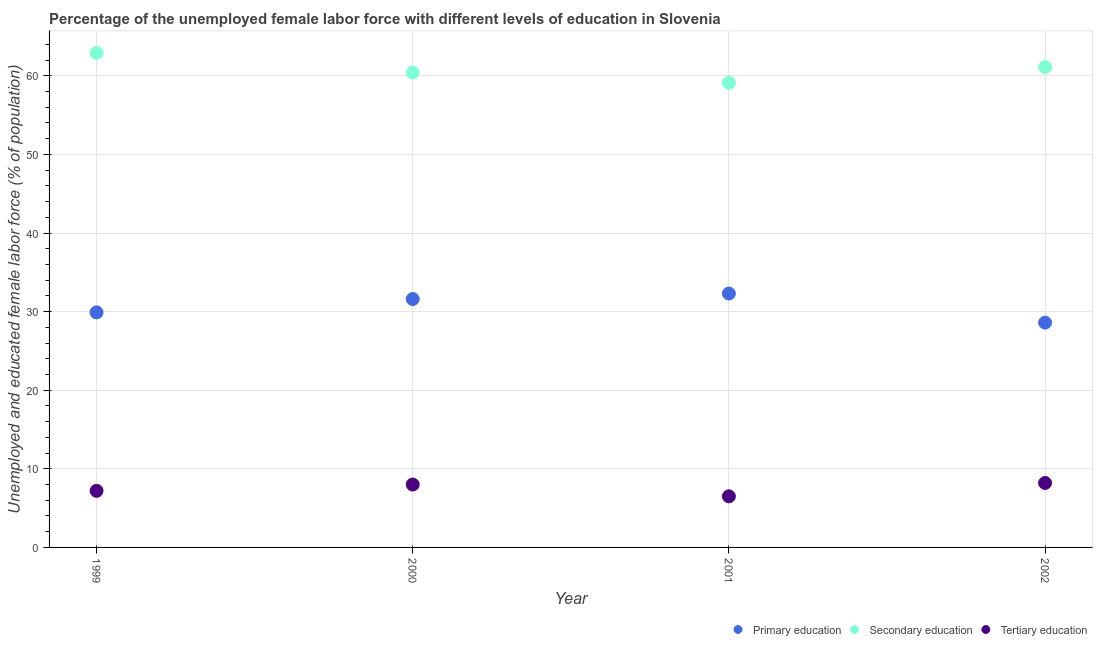Is the number of dotlines equal to the number of legend labels?
Give a very brief answer. Yes. What is the percentage of female labor force who received secondary education in 2002?
Your answer should be compact. 61.1. Across all years, what is the maximum percentage of female labor force who received primary education?
Keep it short and to the point. 32.3. Across all years, what is the minimum percentage of female labor force who received tertiary education?
Provide a succinct answer. 6.5. In which year was the percentage of female labor force who received primary education maximum?
Offer a terse response. 2001. What is the total percentage of female labor force who received tertiary education in the graph?
Your answer should be very brief. 29.9. What is the difference between the percentage of female labor force who received primary education in 1999 and that in 2001?
Your response must be concise. -2.4. What is the difference between the percentage of female labor force who received secondary education in 1999 and the percentage of female labor force who received primary education in 2000?
Provide a succinct answer. 31.3. What is the average percentage of female labor force who received tertiary education per year?
Provide a short and direct response. 7.47. In the year 2001, what is the difference between the percentage of female labor force who received primary education and percentage of female labor force who received tertiary education?
Your response must be concise. 25.8. In how many years, is the percentage of female labor force who received secondary education greater than 20 %?
Give a very brief answer. 4. What is the ratio of the percentage of female labor force who received secondary education in 1999 to that in 2000?
Your response must be concise. 1.04. Is the difference between the percentage of female labor force who received tertiary education in 1999 and 2002 greater than the difference between the percentage of female labor force who received secondary education in 1999 and 2002?
Your answer should be very brief. No. What is the difference between the highest and the second highest percentage of female labor force who received primary education?
Keep it short and to the point. 0.7. What is the difference between the highest and the lowest percentage of female labor force who received primary education?
Make the answer very short. 3.7. In how many years, is the percentage of female labor force who received primary education greater than the average percentage of female labor force who received primary education taken over all years?
Ensure brevity in your answer.  2. Is it the case that in every year, the sum of the percentage of female labor force who received primary education and percentage of female labor force who received secondary education is greater than the percentage of female labor force who received tertiary education?
Give a very brief answer. Yes. Does the percentage of female labor force who received primary education monotonically increase over the years?
Your response must be concise. No. Is the percentage of female labor force who received tertiary education strictly greater than the percentage of female labor force who received secondary education over the years?
Give a very brief answer. No. Is the percentage of female labor force who received tertiary education strictly less than the percentage of female labor force who received primary education over the years?
Offer a very short reply. Yes. How many dotlines are there?
Offer a very short reply. 3. What is the difference between two consecutive major ticks on the Y-axis?
Ensure brevity in your answer.  10. Are the values on the major ticks of Y-axis written in scientific E-notation?
Your answer should be compact. No. Does the graph contain any zero values?
Your answer should be compact. No. How are the legend labels stacked?
Keep it short and to the point. Horizontal. What is the title of the graph?
Your response must be concise. Percentage of the unemployed female labor force with different levels of education in Slovenia. What is the label or title of the Y-axis?
Keep it short and to the point. Unemployed and educated female labor force (% of population). What is the Unemployed and educated female labor force (% of population) of Primary education in 1999?
Your answer should be very brief. 29.9. What is the Unemployed and educated female labor force (% of population) in Secondary education in 1999?
Make the answer very short. 62.9. What is the Unemployed and educated female labor force (% of population) of Tertiary education in 1999?
Your answer should be very brief. 7.2. What is the Unemployed and educated female labor force (% of population) of Primary education in 2000?
Give a very brief answer. 31.6. What is the Unemployed and educated female labor force (% of population) of Secondary education in 2000?
Offer a terse response. 60.4. What is the Unemployed and educated female labor force (% of population) in Primary education in 2001?
Make the answer very short. 32.3. What is the Unemployed and educated female labor force (% of population) in Secondary education in 2001?
Make the answer very short. 59.1. What is the Unemployed and educated female labor force (% of population) in Primary education in 2002?
Ensure brevity in your answer.  28.6. What is the Unemployed and educated female labor force (% of population) in Secondary education in 2002?
Your answer should be compact. 61.1. What is the Unemployed and educated female labor force (% of population) of Tertiary education in 2002?
Provide a short and direct response. 8.2. Across all years, what is the maximum Unemployed and educated female labor force (% of population) in Primary education?
Offer a terse response. 32.3. Across all years, what is the maximum Unemployed and educated female labor force (% of population) in Secondary education?
Give a very brief answer. 62.9. Across all years, what is the maximum Unemployed and educated female labor force (% of population) of Tertiary education?
Your answer should be very brief. 8.2. Across all years, what is the minimum Unemployed and educated female labor force (% of population) in Primary education?
Your answer should be very brief. 28.6. Across all years, what is the minimum Unemployed and educated female labor force (% of population) in Secondary education?
Your answer should be compact. 59.1. Across all years, what is the minimum Unemployed and educated female labor force (% of population) in Tertiary education?
Ensure brevity in your answer.  6.5. What is the total Unemployed and educated female labor force (% of population) in Primary education in the graph?
Ensure brevity in your answer.  122.4. What is the total Unemployed and educated female labor force (% of population) of Secondary education in the graph?
Provide a succinct answer. 243.5. What is the total Unemployed and educated female labor force (% of population) of Tertiary education in the graph?
Offer a terse response. 29.9. What is the difference between the Unemployed and educated female labor force (% of population) in Primary education in 1999 and that in 2001?
Provide a succinct answer. -2.4. What is the difference between the Unemployed and educated female labor force (% of population) of Secondary education in 1999 and that in 2002?
Offer a very short reply. 1.8. What is the difference between the Unemployed and educated female labor force (% of population) in Secondary education in 2000 and that in 2001?
Provide a short and direct response. 1.3. What is the difference between the Unemployed and educated female labor force (% of population) of Tertiary education in 2000 and that in 2001?
Your response must be concise. 1.5. What is the difference between the Unemployed and educated female labor force (% of population) of Primary education in 2001 and that in 2002?
Provide a short and direct response. 3.7. What is the difference between the Unemployed and educated female labor force (% of population) of Tertiary education in 2001 and that in 2002?
Offer a terse response. -1.7. What is the difference between the Unemployed and educated female labor force (% of population) of Primary education in 1999 and the Unemployed and educated female labor force (% of population) of Secondary education in 2000?
Your response must be concise. -30.5. What is the difference between the Unemployed and educated female labor force (% of population) of Primary education in 1999 and the Unemployed and educated female labor force (% of population) of Tertiary education in 2000?
Offer a terse response. 21.9. What is the difference between the Unemployed and educated female labor force (% of population) in Secondary education in 1999 and the Unemployed and educated female labor force (% of population) in Tertiary education in 2000?
Make the answer very short. 54.9. What is the difference between the Unemployed and educated female labor force (% of population) in Primary education in 1999 and the Unemployed and educated female labor force (% of population) in Secondary education in 2001?
Provide a short and direct response. -29.2. What is the difference between the Unemployed and educated female labor force (% of population) of Primary education in 1999 and the Unemployed and educated female labor force (% of population) of Tertiary education in 2001?
Offer a terse response. 23.4. What is the difference between the Unemployed and educated female labor force (% of population) in Secondary education in 1999 and the Unemployed and educated female labor force (% of population) in Tertiary education in 2001?
Make the answer very short. 56.4. What is the difference between the Unemployed and educated female labor force (% of population) in Primary education in 1999 and the Unemployed and educated female labor force (% of population) in Secondary education in 2002?
Offer a terse response. -31.2. What is the difference between the Unemployed and educated female labor force (% of population) of Primary education in 1999 and the Unemployed and educated female labor force (% of population) of Tertiary education in 2002?
Your response must be concise. 21.7. What is the difference between the Unemployed and educated female labor force (% of population) in Secondary education in 1999 and the Unemployed and educated female labor force (% of population) in Tertiary education in 2002?
Your answer should be compact. 54.7. What is the difference between the Unemployed and educated female labor force (% of population) in Primary education in 2000 and the Unemployed and educated female labor force (% of population) in Secondary education in 2001?
Offer a terse response. -27.5. What is the difference between the Unemployed and educated female labor force (% of population) in Primary education in 2000 and the Unemployed and educated female labor force (% of population) in Tertiary education in 2001?
Provide a succinct answer. 25.1. What is the difference between the Unemployed and educated female labor force (% of population) in Secondary education in 2000 and the Unemployed and educated female labor force (% of population) in Tertiary education in 2001?
Offer a very short reply. 53.9. What is the difference between the Unemployed and educated female labor force (% of population) in Primary education in 2000 and the Unemployed and educated female labor force (% of population) in Secondary education in 2002?
Give a very brief answer. -29.5. What is the difference between the Unemployed and educated female labor force (% of population) in Primary education in 2000 and the Unemployed and educated female labor force (% of population) in Tertiary education in 2002?
Offer a terse response. 23.4. What is the difference between the Unemployed and educated female labor force (% of population) of Secondary education in 2000 and the Unemployed and educated female labor force (% of population) of Tertiary education in 2002?
Provide a short and direct response. 52.2. What is the difference between the Unemployed and educated female labor force (% of population) in Primary education in 2001 and the Unemployed and educated female labor force (% of population) in Secondary education in 2002?
Ensure brevity in your answer.  -28.8. What is the difference between the Unemployed and educated female labor force (% of population) of Primary education in 2001 and the Unemployed and educated female labor force (% of population) of Tertiary education in 2002?
Offer a terse response. 24.1. What is the difference between the Unemployed and educated female labor force (% of population) in Secondary education in 2001 and the Unemployed and educated female labor force (% of population) in Tertiary education in 2002?
Make the answer very short. 50.9. What is the average Unemployed and educated female labor force (% of population) of Primary education per year?
Your answer should be very brief. 30.6. What is the average Unemployed and educated female labor force (% of population) in Secondary education per year?
Make the answer very short. 60.88. What is the average Unemployed and educated female labor force (% of population) of Tertiary education per year?
Provide a short and direct response. 7.47. In the year 1999, what is the difference between the Unemployed and educated female labor force (% of population) of Primary education and Unemployed and educated female labor force (% of population) of Secondary education?
Your answer should be very brief. -33. In the year 1999, what is the difference between the Unemployed and educated female labor force (% of population) of Primary education and Unemployed and educated female labor force (% of population) of Tertiary education?
Provide a succinct answer. 22.7. In the year 1999, what is the difference between the Unemployed and educated female labor force (% of population) in Secondary education and Unemployed and educated female labor force (% of population) in Tertiary education?
Offer a terse response. 55.7. In the year 2000, what is the difference between the Unemployed and educated female labor force (% of population) of Primary education and Unemployed and educated female labor force (% of population) of Secondary education?
Your answer should be very brief. -28.8. In the year 2000, what is the difference between the Unemployed and educated female labor force (% of population) in Primary education and Unemployed and educated female labor force (% of population) in Tertiary education?
Provide a succinct answer. 23.6. In the year 2000, what is the difference between the Unemployed and educated female labor force (% of population) of Secondary education and Unemployed and educated female labor force (% of population) of Tertiary education?
Give a very brief answer. 52.4. In the year 2001, what is the difference between the Unemployed and educated female labor force (% of population) of Primary education and Unemployed and educated female labor force (% of population) of Secondary education?
Your answer should be compact. -26.8. In the year 2001, what is the difference between the Unemployed and educated female labor force (% of population) in Primary education and Unemployed and educated female labor force (% of population) in Tertiary education?
Your answer should be very brief. 25.8. In the year 2001, what is the difference between the Unemployed and educated female labor force (% of population) of Secondary education and Unemployed and educated female labor force (% of population) of Tertiary education?
Offer a very short reply. 52.6. In the year 2002, what is the difference between the Unemployed and educated female labor force (% of population) in Primary education and Unemployed and educated female labor force (% of population) in Secondary education?
Offer a terse response. -32.5. In the year 2002, what is the difference between the Unemployed and educated female labor force (% of population) of Primary education and Unemployed and educated female labor force (% of population) of Tertiary education?
Ensure brevity in your answer.  20.4. In the year 2002, what is the difference between the Unemployed and educated female labor force (% of population) of Secondary education and Unemployed and educated female labor force (% of population) of Tertiary education?
Keep it short and to the point. 52.9. What is the ratio of the Unemployed and educated female labor force (% of population) in Primary education in 1999 to that in 2000?
Your answer should be compact. 0.95. What is the ratio of the Unemployed and educated female labor force (% of population) in Secondary education in 1999 to that in 2000?
Your response must be concise. 1.04. What is the ratio of the Unemployed and educated female labor force (% of population) in Primary education in 1999 to that in 2001?
Your answer should be very brief. 0.93. What is the ratio of the Unemployed and educated female labor force (% of population) of Secondary education in 1999 to that in 2001?
Keep it short and to the point. 1.06. What is the ratio of the Unemployed and educated female labor force (% of population) of Tertiary education in 1999 to that in 2001?
Provide a succinct answer. 1.11. What is the ratio of the Unemployed and educated female labor force (% of population) of Primary education in 1999 to that in 2002?
Make the answer very short. 1.05. What is the ratio of the Unemployed and educated female labor force (% of population) of Secondary education in 1999 to that in 2002?
Offer a very short reply. 1.03. What is the ratio of the Unemployed and educated female labor force (% of population) of Tertiary education in 1999 to that in 2002?
Make the answer very short. 0.88. What is the ratio of the Unemployed and educated female labor force (% of population) of Primary education in 2000 to that in 2001?
Your answer should be very brief. 0.98. What is the ratio of the Unemployed and educated female labor force (% of population) in Tertiary education in 2000 to that in 2001?
Give a very brief answer. 1.23. What is the ratio of the Unemployed and educated female labor force (% of population) in Primary education in 2000 to that in 2002?
Make the answer very short. 1.1. What is the ratio of the Unemployed and educated female labor force (% of population) in Secondary education in 2000 to that in 2002?
Keep it short and to the point. 0.99. What is the ratio of the Unemployed and educated female labor force (% of population) of Tertiary education in 2000 to that in 2002?
Your response must be concise. 0.98. What is the ratio of the Unemployed and educated female labor force (% of population) in Primary education in 2001 to that in 2002?
Give a very brief answer. 1.13. What is the ratio of the Unemployed and educated female labor force (% of population) in Secondary education in 2001 to that in 2002?
Ensure brevity in your answer.  0.97. What is the ratio of the Unemployed and educated female labor force (% of population) in Tertiary education in 2001 to that in 2002?
Offer a terse response. 0.79. What is the difference between the highest and the second highest Unemployed and educated female labor force (% of population) of Primary education?
Your response must be concise. 0.7. What is the difference between the highest and the lowest Unemployed and educated female labor force (% of population) of Secondary education?
Provide a succinct answer. 3.8. What is the difference between the highest and the lowest Unemployed and educated female labor force (% of population) in Tertiary education?
Your answer should be very brief. 1.7. 